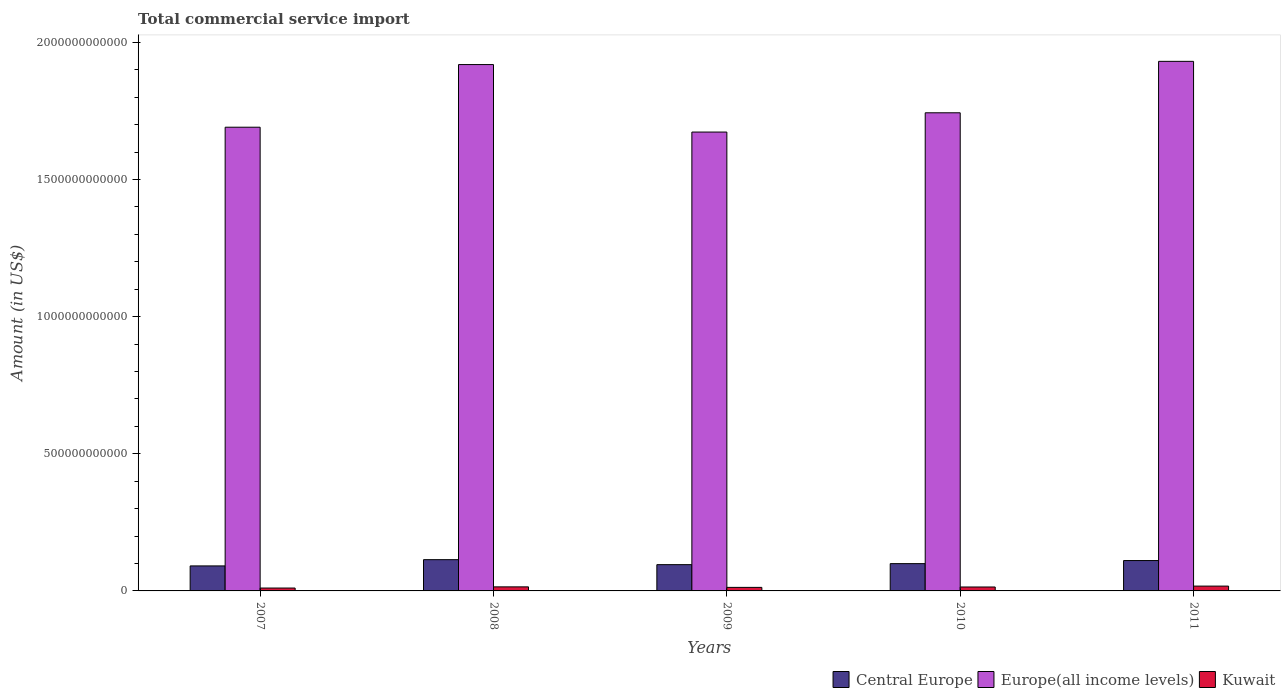How many different coloured bars are there?
Your answer should be compact. 3. How many bars are there on the 5th tick from the right?
Make the answer very short. 3. In how many cases, is the number of bars for a given year not equal to the number of legend labels?
Your answer should be very brief. 0. What is the total commercial service import in Europe(all income levels) in 2008?
Ensure brevity in your answer.  1.92e+12. Across all years, what is the maximum total commercial service import in Kuwait?
Provide a short and direct response. 1.76e+1. Across all years, what is the minimum total commercial service import in Kuwait?
Your response must be concise. 1.05e+1. In which year was the total commercial service import in Europe(all income levels) maximum?
Your answer should be compact. 2011. What is the total total commercial service import in Kuwait in the graph?
Your answer should be very brief. 7.01e+1. What is the difference between the total commercial service import in Europe(all income levels) in 2008 and that in 2010?
Keep it short and to the point. 1.76e+11. What is the difference between the total commercial service import in Kuwait in 2007 and the total commercial service import in Central Europe in 2009?
Your answer should be very brief. -8.53e+1. What is the average total commercial service import in Kuwait per year?
Offer a terse response. 1.40e+1. In the year 2008, what is the difference between the total commercial service import in Central Europe and total commercial service import in Kuwait?
Your response must be concise. 9.92e+1. What is the ratio of the total commercial service import in Central Europe in 2007 to that in 2011?
Your answer should be compact. 0.82. Is the difference between the total commercial service import in Central Europe in 2008 and 2011 greater than the difference between the total commercial service import in Kuwait in 2008 and 2011?
Make the answer very short. Yes. What is the difference between the highest and the second highest total commercial service import in Europe(all income levels)?
Make the answer very short. 1.17e+1. What is the difference between the highest and the lowest total commercial service import in Central Europe?
Provide a short and direct response. 2.28e+1. In how many years, is the total commercial service import in Central Europe greater than the average total commercial service import in Central Europe taken over all years?
Give a very brief answer. 2. What does the 3rd bar from the left in 2010 represents?
Your answer should be compact. Kuwait. What does the 1st bar from the right in 2008 represents?
Provide a succinct answer. Kuwait. How many bars are there?
Your response must be concise. 15. Are all the bars in the graph horizontal?
Your answer should be compact. No. How many years are there in the graph?
Ensure brevity in your answer.  5. What is the difference between two consecutive major ticks on the Y-axis?
Offer a very short reply. 5.00e+11. Does the graph contain grids?
Your answer should be very brief. No. How many legend labels are there?
Provide a succinct answer. 3. How are the legend labels stacked?
Provide a short and direct response. Horizontal. What is the title of the graph?
Your answer should be compact. Total commercial service import. What is the label or title of the X-axis?
Your answer should be compact. Years. What is the Amount (in US$) in Central Europe in 2007?
Keep it short and to the point. 9.12e+1. What is the Amount (in US$) of Europe(all income levels) in 2007?
Provide a short and direct response. 1.69e+12. What is the Amount (in US$) in Kuwait in 2007?
Offer a very short reply. 1.05e+1. What is the Amount (in US$) in Central Europe in 2008?
Provide a succinct answer. 1.14e+11. What is the Amount (in US$) in Europe(all income levels) in 2008?
Provide a succinct answer. 1.92e+12. What is the Amount (in US$) in Kuwait in 2008?
Your answer should be compact. 1.48e+1. What is the Amount (in US$) in Central Europe in 2009?
Ensure brevity in your answer.  9.58e+1. What is the Amount (in US$) of Europe(all income levels) in 2009?
Make the answer very short. 1.67e+12. What is the Amount (in US$) of Kuwait in 2009?
Provide a succinct answer. 1.29e+1. What is the Amount (in US$) in Central Europe in 2010?
Your answer should be compact. 9.95e+1. What is the Amount (in US$) of Europe(all income levels) in 2010?
Keep it short and to the point. 1.74e+12. What is the Amount (in US$) of Kuwait in 2010?
Ensure brevity in your answer.  1.43e+1. What is the Amount (in US$) of Central Europe in 2011?
Keep it short and to the point. 1.11e+11. What is the Amount (in US$) of Europe(all income levels) in 2011?
Provide a short and direct response. 1.93e+12. What is the Amount (in US$) of Kuwait in 2011?
Your response must be concise. 1.76e+1. Across all years, what is the maximum Amount (in US$) of Central Europe?
Give a very brief answer. 1.14e+11. Across all years, what is the maximum Amount (in US$) in Europe(all income levels)?
Ensure brevity in your answer.  1.93e+12. Across all years, what is the maximum Amount (in US$) in Kuwait?
Offer a terse response. 1.76e+1. Across all years, what is the minimum Amount (in US$) in Central Europe?
Provide a short and direct response. 9.12e+1. Across all years, what is the minimum Amount (in US$) in Europe(all income levels)?
Provide a succinct answer. 1.67e+12. Across all years, what is the minimum Amount (in US$) in Kuwait?
Provide a succinct answer. 1.05e+1. What is the total Amount (in US$) of Central Europe in the graph?
Offer a very short reply. 5.11e+11. What is the total Amount (in US$) of Europe(all income levels) in the graph?
Provide a succinct answer. 8.96e+12. What is the total Amount (in US$) of Kuwait in the graph?
Your answer should be compact. 7.01e+1. What is the difference between the Amount (in US$) in Central Europe in 2007 and that in 2008?
Ensure brevity in your answer.  -2.28e+1. What is the difference between the Amount (in US$) of Europe(all income levels) in 2007 and that in 2008?
Make the answer very short. -2.28e+11. What is the difference between the Amount (in US$) of Kuwait in 2007 and that in 2008?
Provide a succinct answer. -4.30e+09. What is the difference between the Amount (in US$) of Central Europe in 2007 and that in 2009?
Provide a short and direct response. -4.61e+09. What is the difference between the Amount (in US$) of Europe(all income levels) in 2007 and that in 2009?
Make the answer very short. 1.76e+1. What is the difference between the Amount (in US$) in Kuwait in 2007 and that in 2009?
Offer a very short reply. -2.39e+09. What is the difference between the Amount (in US$) in Central Europe in 2007 and that in 2010?
Your response must be concise. -8.32e+09. What is the difference between the Amount (in US$) of Europe(all income levels) in 2007 and that in 2010?
Give a very brief answer. -5.26e+1. What is the difference between the Amount (in US$) of Kuwait in 2007 and that in 2010?
Offer a terse response. -3.83e+09. What is the difference between the Amount (in US$) of Central Europe in 2007 and that in 2011?
Your answer should be compact. -1.95e+1. What is the difference between the Amount (in US$) in Europe(all income levels) in 2007 and that in 2011?
Offer a very short reply. -2.40e+11. What is the difference between the Amount (in US$) of Kuwait in 2007 and that in 2011?
Offer a terse response. -7.09e+09. What is the difference between the Amount (in US$) of Central Europe in 2008 and that in 2009?
Make the answer very short. 1.82e+1. What is the difference between the Amount (in US$) in Europe(all income levels) in 2008 and that in 2009?
Offer a terse response. 2.46e+11. What is the difference between the Amount (in US$) in Kuwait in 2008 and that in 2009?
Your answer should be very brief. 1.91e+09. What is the difference between the Amount (in US$) in Central Europe in 2008 and that in 2010?
Your response must be concise. 1.45e+1. What is the difference between the Amount (in US$) of Europe(all income levels) in 2008 and that in 2010?
Make the answer very short. 1.76e+11. What is the difference between the Amount (in US$) of Kuwait in 2008 and that in 2010?
Your answer should be very brief. 4.76e+08. What is the difference between the Amount (in US$) of Central Europe in 2008 and that in 2011?
Offer a terse response. 3.25e+09. What is the difference between the Amount (in US$) in Europe(all income levels) in 2008 and that in 2011?
Your answer should be compact. -1.17e+1. What is the difference between the Amount (in US$) in Kuwait in 2008 and that in 2011?
Keep it short and to the point. -2.79e+09. What is the difference between the Amount (in US$) in Central Europe in 2009 and that in 2010?
Your answer should be compact. -3.71e+09. What is the difference between the Amount (in US$) of Europe(all income levels) in 2009 and that in 2010?
Provide a short and direct response. -7.02e+1. What is the difference between the Amount (in US$) in Kuwait in 2009 and that in 2010?
Your response must be concise. -1.44e+09. What is the difference between the Amount (in US$) in Central Europe in 2009 and that in 2011?
Provide a succinct answer. -1.49e+1. What is the difference between the Amount (in US$) in Europe(all income levels) in 2009 and that in 2011?
Provide a succinct answer. -2.58e+11. What is the difference between the Amount (in US$) of Kuwait in 2009 and that in 2011?
Provide a short and direct response. -4.70e+09. What is the difference between the Amount (in US$) of Central Europe in 2010 and that in 2011?
Give a very brief answer. -1.12e+1. What is the difference between the Amount (in US$) of Europe(all income levels) in 2010 and that in 2011?
Provide a succinct answer. -1.88e+11. What is the difference between the Amount (in US$) in Kuwait in 2010 and that in 2011?
Keep it short and to the point. -3.26e+09. What is the difference between the Amount (in US$) in Central Europe in 2007 and the Amount (in US$) in Europe(all income levels) in 2008?
Offer a very short reply. -1.83e+12. What is the difference between the Amount (in US$) in Central Europe in 2007 and the Amount (in US$) in Kuwait in 2008?
Your response must be concise. 7.64e+1. What is the difference between the Amount (in US$) in Europe(all income levels) in 2007 and the Amount (in US$) in Kuwait in 2008?
Provide a short and direct response. 1.68e+12. What is the difference between the Amount (in US$) in Central Europe in 2007 and the Amount (in US$) in Europe(all income levels) in 2009?
Provide a succinct answer. -1.58e+12. What is the difference between the Amount (in US$) of Central Europe in 2007 and the Amount (in US$) of Kuwait in 2009?
Keep it short and to the point. 7.83e+1. What is the difference between the Amount (in US$) of Europe(all income levels) in 2007 and the Amount (in US$) of Kuwait in 2009?
Your response must be concise. 1.68e+12. What is the difference between the Amount (in US$) in Central Europe in 2007 and the Amount (in US$) in Europe(all income levels) in 2010?
Your answer should be very brief. -1.65e+12. What is the difference between the Amount (in US$) in Central Europe in 2007 and the Amount (in US$) in Kuwait in 2010?
Keep it short and to the point. 7.69e+1. What is the difference between the Amount (in US$) of Europe(all income levels) in 2007 and the Amount (in US$) of Kuwait in 2010?
Provide a succinct answer. 1.68e+12. What is the difference between the Amount (in US$) in Central Europe in 2007 and the Amount (in US$) in Europe(all income levels) in 2011?
Make the answer very short. -1.84e+12. What is the difference between the Amount (in US$) in Central Europe in 2007 and the Amount (in US$) in Kuwait in 2011?
Your answer should be very brief. 7.36e+1. What is the difference between the Amount (in US$) of Europe(all income levels) in 2007 and the Amount (in US$) of Kuwait in 2011?
Make the answer very short. 1.67e+12. What is the difference between the Amount (in US$) of Central Europe in 2008 and the Amount (in US$) of Europe(all income levels) in 2009?
Ensure brevity in your answer.  -1.56e+12. What is the difference between the Amount (in US$) in Central Europe in 2008 and the Amount (in US$) in Kuwait in 2009?
Offer a very short reply. 1.01e+11. What is the difference between the Amount (in US$) of Europe(all income levels) in 2008 and the Amount (in US$) of Kuwait in 2009?
Ensure brevity in your answer.  1.91e+12. What is the difference between the Amount (in US$) in Central Europe in 2008 and the Amount (in US$) in Europe(all income levels) in 2010?
Provide a succinct answer. -1.63e+12. What is the difference between the Amount (in US$) of Central Europe in 2008 and the Amount (in US$) of Kuwait in 2010?
Offer a very short reply. 9.97e+1. What is the difference between the Amount (in US$) of Europe(all income levels) in 2008 and the Amount (in US$) of Kuwait in 2010?
Keep it short and to the point. 1.90e+12. What is the difference between the Amount (in US$) of Central Europe in 2008 and the Amount (in US$) of Europe(all income levels) in 2011?
Make the answer very short. -1.82e+12. What is the difference between the Amount (in US$) of Central Europe in 2008 and the Amount (in US$) of Kuwait in 2011?
Give a very brief answer. 9.64e+1. What is the difference between the Amount (in US$) of Europe(all income levels) in 2008 and the Amount (in US$) of Kuwait in 2011?
Your answer should be very brief. 1.90e+12. What is the difference between the Amount (in US$) in Central Europe in 2009 and the Amount (in US$) in Europe(all income levels) in 2010?
Offer a very short reply. -1.65e+12. What is the difference between the Amount (in US$) of Central Europe in 2009 and the Amount (in US$) of Kuwait in 2010?
Give a very brief answer. 8.15e+1. What is the difference between the Amount (in US$) of Europe(all income levels) in 2009 and the Amount (in US$) of Kuwait in 2010?
Offer a terse response. 1.66e+12. What is the difference between the Amount (in US$) of Central Europe in 2009 and the Amount (in US$) of Europe(all income levels) in 2011?
Make the answer very short. -1.84e+12. What is the difference between the Amount (in US$) in Central Europe in 2009 and the Amount (in US$) in Kuwait in 2011?
Your response must be concise. 7.82e+1. What is the difference between the Amount (in US$) of Europe(all income levels) in 2009 and the Amount (in US$) of Kuwait in 2011?
Your response must be concise. 1.66e+12. What is the difference between the Amount (in US$) of Central Europe in 2010 and the Amount (in US$) of Europe(all income levels) in 2011?
Provide a short and direct response. -1.83e+12. What is the difference between the Amount (in US$) of Central Europe in 2010 and the Amount (in US$) of Kuwait in 2011?
Make the answer very short. 8.19e+1. What is the difference between the Amount (in US$) of Europe(all income levels) in 2010 and the Amount (in US$) of Kuwait in 2011?
Offer a very short reply. 1.73e+12. What is the average Amount (in US$) in Central Europe per year?
Ensure brevity in your answer.  1.02e+11. What is the average Amount (in US$) in Europe(all income levels) per year?
Offer a terse response. 1.79e+12. What is the average Amount (in US$) in Kuwait per year?
Provide a short and direct response. 1.40e+1. In the year 2007, what is the difference between the Amount (in US$) of Central Europe and Amount (in US$) of Europe(all income levels)?
Your response must be concise. -1.60e+12. In the year 2007, what is the difference between the Amount (in US$) of Central Europe and Amount (in US$) of Kuwait?
Offer a terse response. 8.07e+1. In the year 2007, what is the difference between the Amount (in US$) of Europe(all income levels) and Amount (in US$) of Kuwait?
Offer a terse response. 1.68e+12. In the year 2008, what is the difference between the Amount (in US$) of Central Europe and Amount (in US$) of Europe(all income levels)?
Your response must be concise. -1.81e+12. In the year 2008, what is the difference between the Amount (in US$) in Central Europe and Amount (in US$) in Kuwait?
Ensure brevity in your answer.  9.92e+1. In the year 2008, what is the difference between the Amount (in US$) of Europe(all income levels) and Amount (in US$) of Kuwait?
Offer a terse response. 1.90e+12. In the year 2009, what is the difference between the Amount (in US$) in Central Europe and Amount (in US$) in Europe(all income levels)?
Your response must be concise. -1.58e+12. In the year 2009, what is the difference between the Amount (in US$) in Central Europe and Amount (in US$) in Kuwait?
Your answer should be very brief. 8.29e+1. In the year 2009, what is the difference between the Amount (in US$) in Europe(all income levels) and Amount (in US$) in Kuwait?
Offer a terse response. 1.66e+12. In the year 2010, what is the difference between the Amount (in US$) of Central Europe and Amount (in US$) of Europe(all income levels)?
Ensure brevity in your answer.  -1.64e+12. In the year 2010, what is the difference between the Amount (in US$) in Central Europe and Amount (in US$) in Kuwait?
Your answer should be compact. 8.52e+1. In the year 2010, what is the difference between the Amount (in US$) of Europe(all income levels) and Amount (in US$) of Kuwait?
Your response must be concise. 1.73e+12. In the year 2011, what is the difference between the Amount (in US$) of Central Europe and Amount (in US$) of Europe(all income levels)?
Give a very brief answer. -1.82e+12. In the year 2011, what is the difference between the Amount (in US$) of Central Europe and Amount (in US$) of Kuwait?
Offer a very short reply. 9.32e+1. In the year 2011, what is the difference between the Amount (in US$) of Europe(all income levels) and Amount (in US$) of Kuwait?
Keep it short and to the point. 1.91e+12. What is the ratio of the Amount (in US$) in Europe(all income levels) in 2007 to that in 2008?
Your answer should be compact. 0.88. What is the ratio of the Amount (in US$) in Kuwait in 2007 to that in 2008?
Make the answer very short. 0.71. What is the ratio of the Amount (in US$) in Central Europe in 2007 to that in 2009?
Ensure brevity in your answer.  0.95. What is the ratio of the Amount (in US$) of Europe(all income levels) in 2007 to that in 2009?
Keep it short and to the point. 1.01. What is the ratio of the Amount (in US$) in Kuwait in 2007 to that in 2009?
Ensure brevity in your answer.  0.81. What is the ratio of the Amount (in US$) in Central Europe in 2007 to that in 2010?
Provide a succinct answer. 0.92. What is the ratio of the Amount (in US$) of Europe(all income levels) in 2007 to that in 2010?
Your response must be concise. 0.97. What is the ratio of the Amount (in US$) of Kuwait in 2007 to that in 2010?
Your response must be concise. 0.73. What is the ratio of the Amount (in US$) of Central Europe in 2007 to that in 2011?
Your answer should be compact. 0.82. What is the ratio of the Amount (in US$) in Europe(all income levels) in 2007 to that in 2011?
Offer a terse response. 0.88. What is the ratio of the Amount (in US$) in Kuwait in 2007 to that in 2011?
Offer a very short reply. 0.6. What is the ratio of the Amount (in US$) of Central Europe in 2008 to that in 2009?
Your answer should be compact. 1.19. What is the ratio of the Amount (in US$) of Europe(all income levels) in 2008 to that in 2009?
Keep it short and to the point. 1.15. What is the ratio of the Amount (in US$) of Kuwait in 2008 to that in 2009?
Provide a short and direct response. 1.15. What is the ratio of the Amount (in US$) in Central Europe in 2008 to that in 2010?
Provide a succinct answer. 1.15. What is the ratio of the Amount (in US$) in Europe(all income levels) in 2008 to that in 2010?
Give a very brief answer. 1.1. What is the ratio of the Amount (in US$) in Central Europe in 2008 to that in 2011?
Make the answer very short. 1.03. What is the ratio of the Amount (in US$) of Kuwait in 2008 to that in 2011?
Provide a short and direct response. 0.84. What is the ratio of the Amount (in US$) in Central Europe in 2009 to that in 2010?
Your response must be concise. 0.96. What is the ratio of the Amount (in US$) in Europe(all income levels) in 2009 to that in 2010?
Your answer should be compact. 0.96. What is the ratio of the Amount (in US$) of Kuwait in 2009 to that in 2010?
Your answer should be very brief. 0.9. What is the ratio of the Amount (in US$) of Central Europe in 2009 to that in 2011?
Your response must be concise. 0.87. What is the ratio of the Amount (in US$) of Europe(all income levels) in 2009 to that in 2011?
Give a very brief answer. 0.87. What is the ratio of the Amount (in US$) of Kuwait in 2009 to that in 2011?
Keep it short and to the point. 0.73. What is the ratio of the Amount (in US$) in Central Europe in 2010 to that in 2011?
Offer a very short reply. 0.9. What is the ratio of the Amount (in US$) of Europe(all income levels) in 2010 to that in 2011?
Make the answer very short. 0.9. What is the ratio of the Amount (in US$) of Kuwait in 2010 to that in 2011?
Your answer should be very brief. 0.81. What is the difference between the highest and the second highest Amount (in US$) in Central Europe?
Give a very brief answer. 3.25e+09. What is the difference between the highest and the second highest Amount (in US$) in Europe(all income levels)?
Give a very brief answer. 1.17e+1. What is the difference between the highest and the second highest Amount (in US$) of Kuwait?
Provide a short and direct response. 2.79e+09. What is the difference between the highest and the lowest Amount (in US$) in Central Europe?
Provide a short and direct response. 2.28e+1. What is the difference between the highest and the lowest Amount (in US$) in Europe(all income levels)?
Provide a short and direct response. 2.58e+11. What is the difference between the highest and the lowest Amount (in US$) in Kuwait?
Provide a short and direct response. 7.09e+09. 